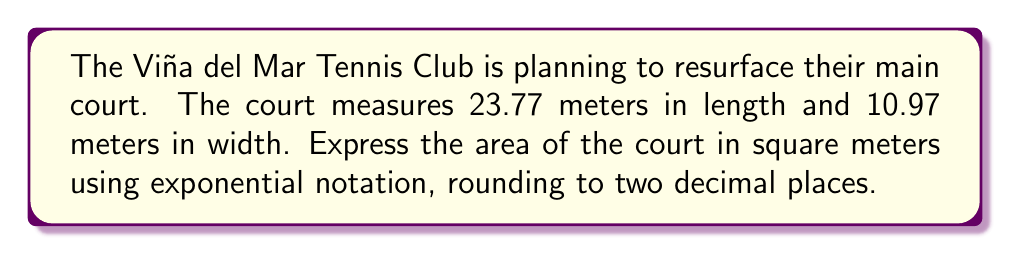Can you solve this math problem? Let's approach this step-by-step:

1) First, we need to calculate the area of the tennis court. The area of a rectangle is given by the formula:

   $A = l \times w$

   where $A$ is the area, $l$ is the length, and $w$ is the width.

2) Substituting the given dimensions:

   $A = 23.77 \text{ m} \times 10.97 \text{ m}$

3) Multiplying these numbers:

   $A = 260.7569 \text{ m}^2$

4) Rounding to two decimal places:

   $A = 260.76 \text{ m}^2$

5) To express this in exponential notation, we need to move the decimal point to the left until we have a number between 1 and 10, and then count how many places we moved:

   $260.76 = 2.6076 \times 10^2$

6) Rounding to two decimal places again:

   $260.76 \approx 2.61 \times 10^2 \text{ m}^2$

This is our final answer in exponential notation.
Answer: $2.61 \times 10^2 \text{ m}^2$ 